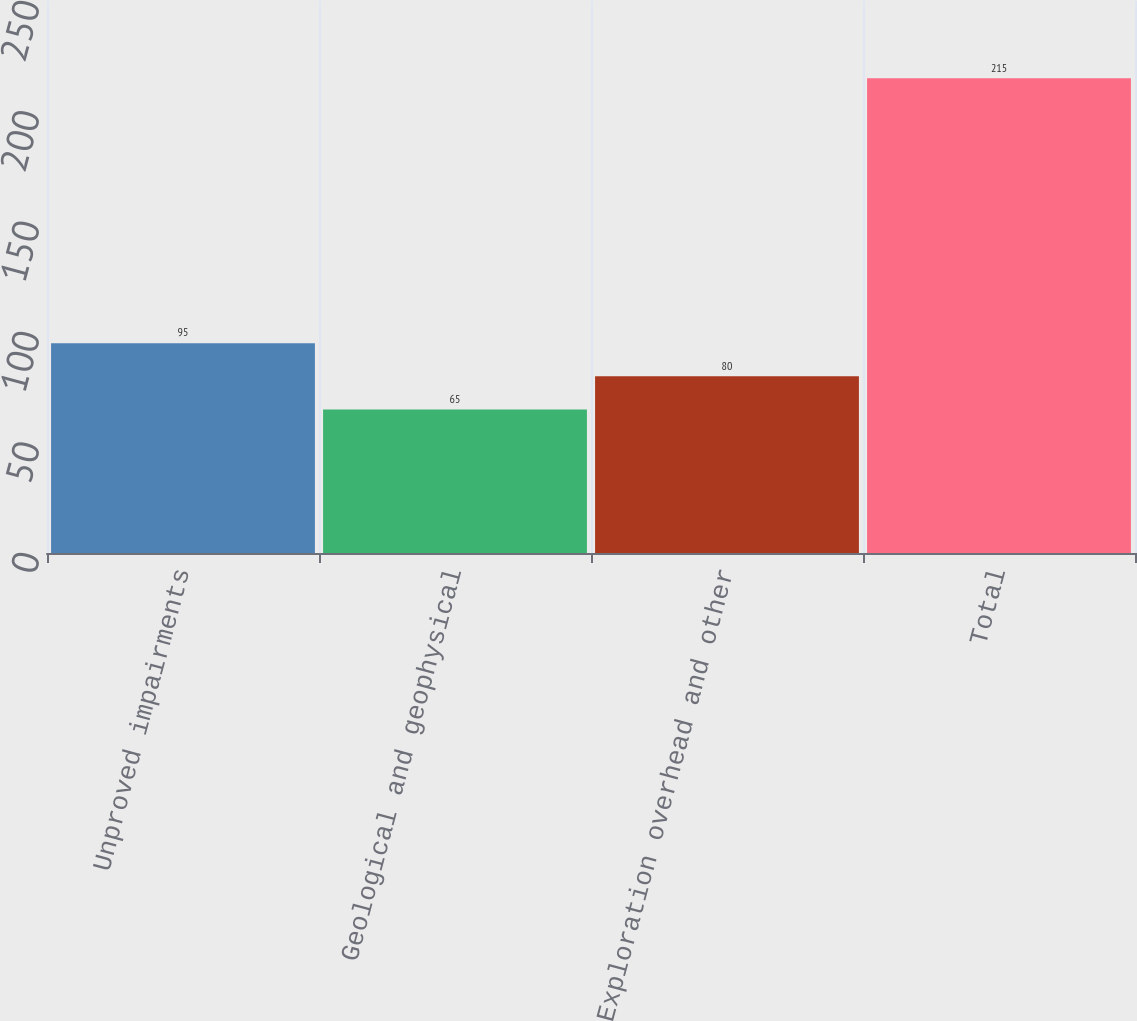Convert chart. <chart><loc_0><loc_0><loc_500><loc_500><bar_chart><fcel>Unproved impairments<fcel>Geological and geophysical<fcel>Exploration overhead and other<fcel>Total<nl><fcel>95<fcel>65<fcel>80<fcel>215<nl></chart> 